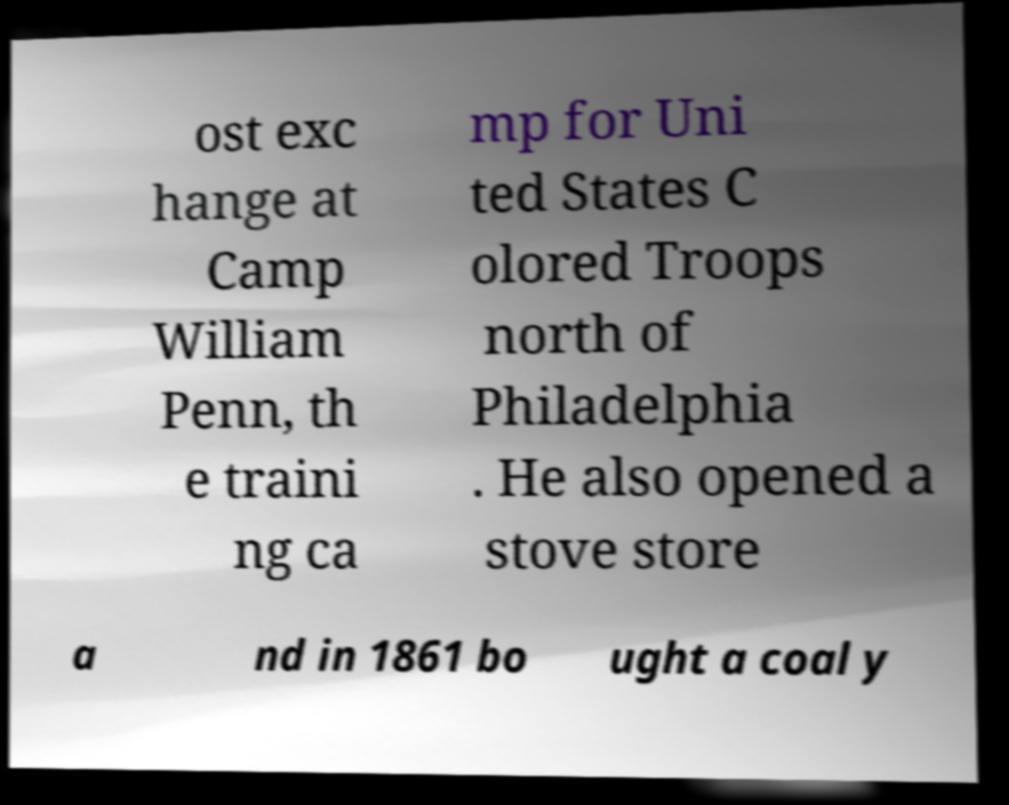Can you read and provide the text displayed in the image?This photo seems to have some interesting text. Can you extract and type it out for me? ost exc hange at Camp William Penn, th e traini ng ca mp for Uni ted States C olored Troops north of Philadelphia . He also opened a stove store a nd in 1861 bo ught a coal y 